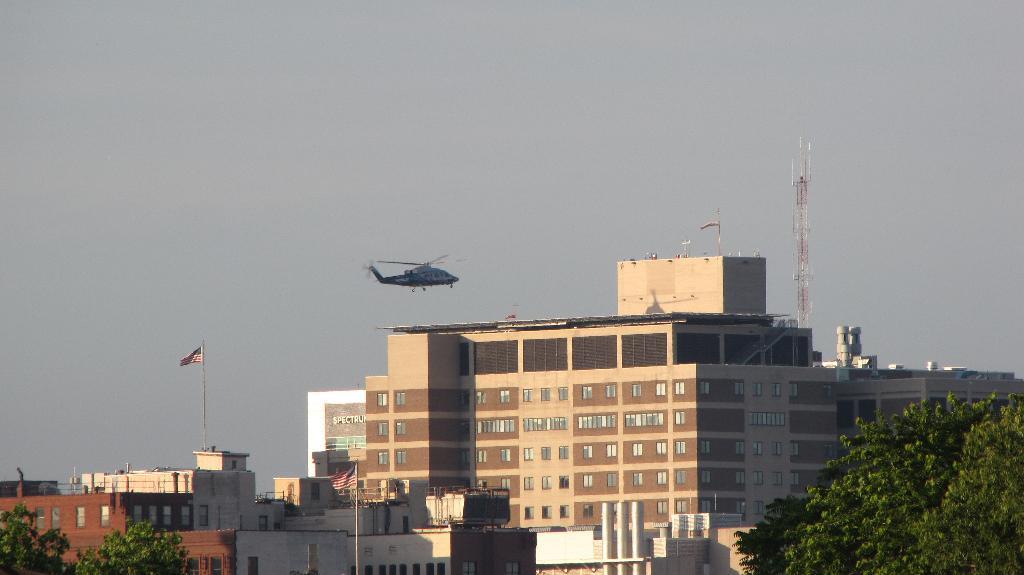How would you summarize this image in a sentence or two? In this image we can see an airplane flying, there are some buildings, trees, flags and a tower, in the background, we can see the sky. 